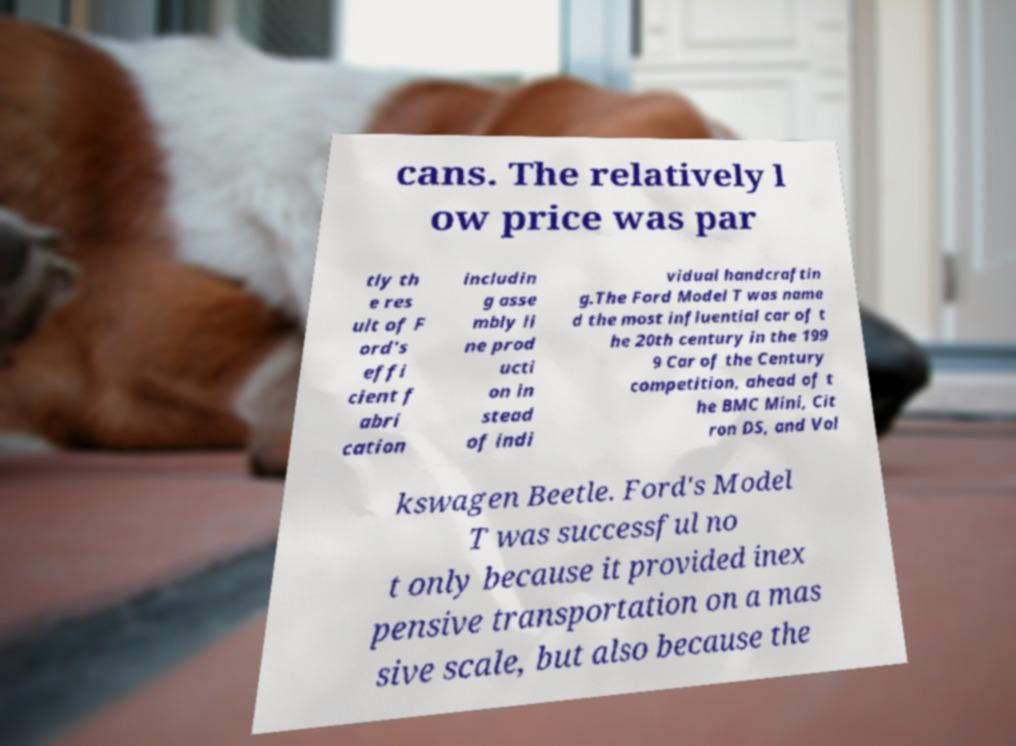What messages or text are displayed in this image? I need them in a readable, typed format. cans. The relatively l ow price was par tly th e res ult of F ord's effi cient f abri cation includin g asse mbly li ne prod ucti on in stead of indi vidual handcraftin g.The Ford Model T was name d the most influential car of t he 20th century in the 199 9 Car of the Century competition, ahead of t he BMC Mini, Cit ron DS, and Vol kswagen Beetle. Ford's Model T was successful no t only because it provided inex pensive transportation on a mas sive scale, but also because the 